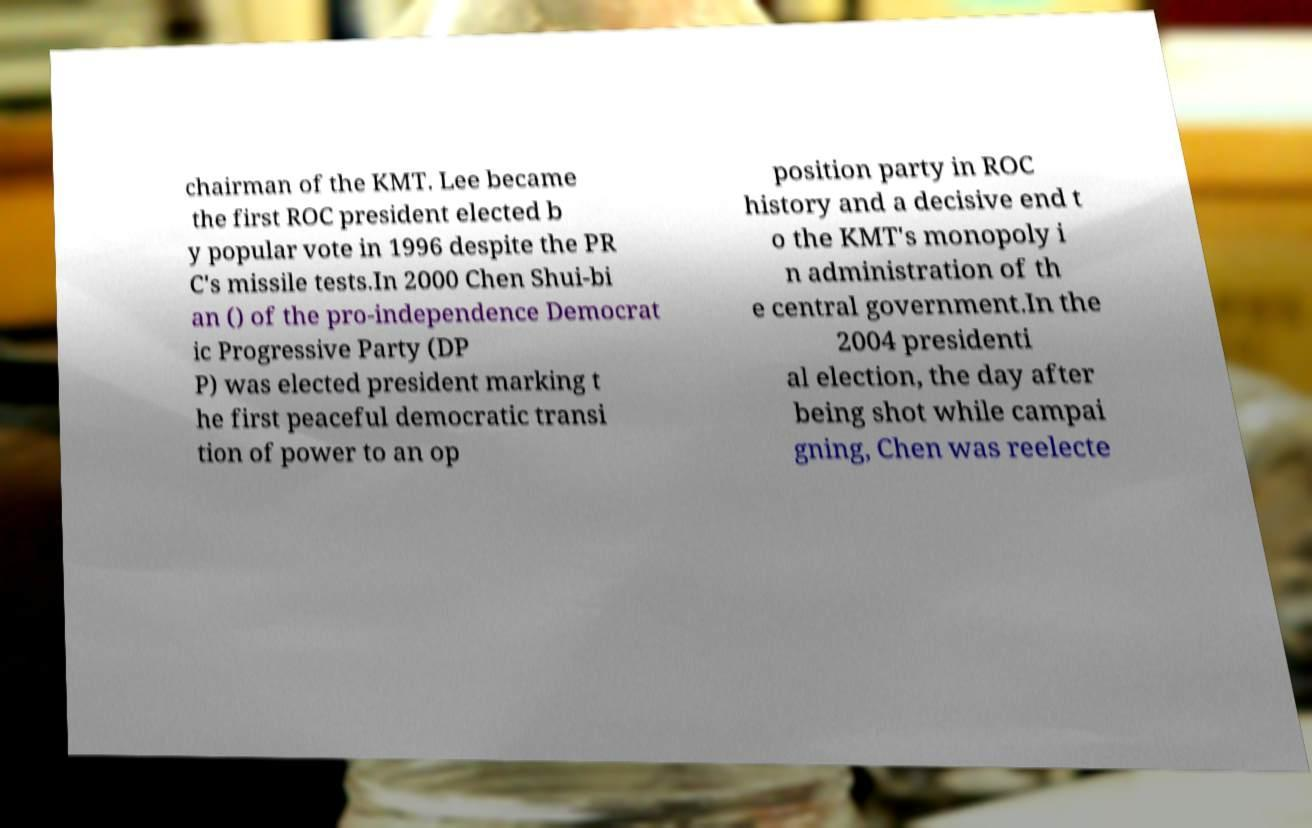For documentation purposes, I need the text within this image transcribed. Could you provide that? chairman of the KMT. Lee became the first ROC president elected b y popular vote in 1996 despite the PR C's missile tests.In 2000 Chen Shui-bi an () of the pro-independence Democrat ic Progressive Party (DP P) was elected president marking t he first peaceful democratic transi tion of power to an op position party in ROC history and a decisive end t o the KMT's monopoly i n administration of th e central government.In the 2004 presidenti al election, the day after being shot while campai gning, Chen was reelecte 